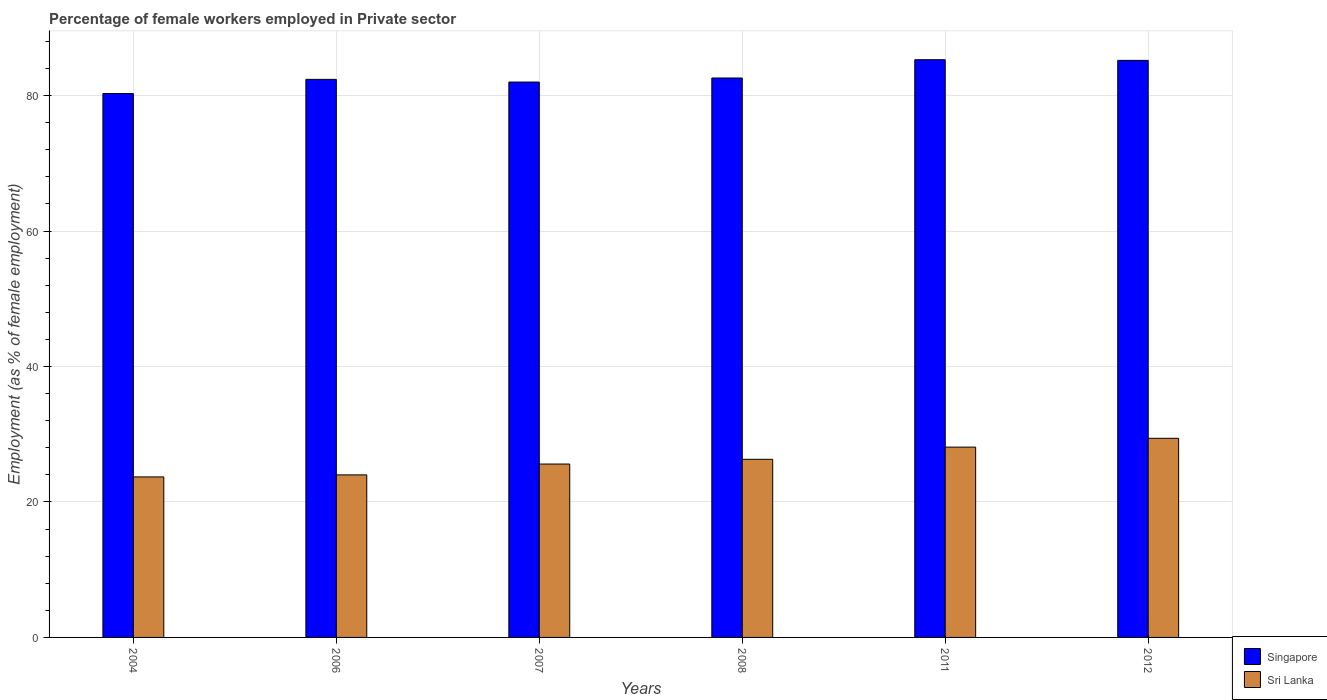How many different coloured bars are there?
Your response must be concise. 2. How many groups of bars are there?
Make the answer very short. 6. Are the number of bars per tick equal to the number of legend labels?
Offer a very short reply. Yes. Are the number of bars on each tick of the X-axis equal?
Your answer should be compact. Yes. In how many cases, is the number of bars for a given year not equal to the number of legend labels?
Provide a short and direct response. 0. What is the percentage of females employed in Private sector in Sri Lanka in 2007?
Offer a very short reply. 25.6. Across all years, what is the maximum percentage of females employed in Private sector in Singapore?
Provide a succinct answer. 85.3. Across all years, what is the minimum percentage of females employed in Private sector in Singapore?
Your answer should be compact. 80.3. What is the total percentage of females employed in Private sector in Singapore in the graph?
Provide a succinct answer. 497.8. What is the difference between the percentage of females employed in Private sector in Singapore in 2006 and that in 2012?
Your response must be concise. -2.8. What is the difference between the percentage of females employed in Private sector in Singapore in 2012 and the percentage of females employed in Private sector in Sri Lanka in 2004?
Ensure brevity in your answer.  61.5. What is the average percentage of females employed in Private sector in Singapore per year?
Your answer should be compact. 82.97. In the year 2011, what is the difference between the percentage of females employed in Private sector in Singapore and percentage of females employed in Private sector in Sri Lanka?
Provide a short and direct response. 57.2. What is the ratio of the percentage of females employed in Private sector in Singapore in 2006 to that in 2011?
Keep it short and to the point. 0.97. Is the percentage of females employed in Private sector in Sri Lanka in 2004 less than that in 2006?
Provide a succinct answer. Yes. What is the difference between the highest and the second highest percentage of females employed in Private sector in Singapore?
Your answer should be very brief. 0.1. What is the difference between the highest and the lowest percentage of females employed in Private sector in Sri Lanka?
Provide a short and direct response. 5.7. In how many years, is the percentage of females employed in Private sector in Sri Lanka greater than the average percentage of females employed in Private sector in Sri Lanka taken over all years?
Ensure brevity in your answer.  3. Is the sum of the percentage of females employed in Private sector in Singapore in 2007 and 2012 greater than the maximum percentage of females employed in Private sector in Sri Lanka across all years?
Offer a terse response. Yes. What does the 1st bar from the left in 2011 represents?
Offer a very short reply. Singapore. What does the 2nd bar from the right in 2006 represents?
Ensure brevity in your answer.  Singapore. Are all the bars in the graph horizontal?
Keep it short and to the point. No. How many years are there in the graph?
Provide a short and direct response. 6. What is the difference between two consecutive major ticks on the Y-axis?
Ensure brevity in your answer.  20. Are the values on the major ticks of Y-axis written in scientific E-notation?
Give a very brief answer. No. Does the graph contain any zero values?
Your answer should be compact. No. What is the title of the graph?
Ensure brevity in your answer.  Percentage of female workers employed in Private sector. What is the label or title of the X-axis?
Provide a succinct answer. Years. What is the label or title of the Y-axis?
Give a very brief answer. Employment (as % of female employment). What is the Employment (as % of female employment) in Singapore in 2004?
Give a very brief answer. 80.3. What is the Employment (as % of female employment) in Sri Lanka in 2004?
Provide a short and direct response. 23.7. What is the Employment (as % of female employment) of Singapore in 2006?
Keep it short and to the point. 82.4. What is the Employment (as % of female employment) in Sri Lanka in 2006?
Provide a short and direct response. 24. What is the Employment (as % of female employment) in Singapore in 2007?
Make the answer very short. 82. What is the Employment (as % of female employment) of Sri Lanka in 2007?
Give a very brief answer. 25.6. What is the Employment (as % of female employment) in Singapore in 2008?
Your answer should be compact. 82.6. What is the Employment (as % of female employment) in Sri Lanka in 2008?
Offer a very short reply. 26.3. What is the Employment (as % of female employment) in Singapore in 2011?
Keep it short and to the point. 85.3. What is the Employment (as % of female employment) of Sri Lanka in 2011?
Offer a very short reply. 28.1. What is the Employment (as % of female employment) in Singapore in 2012?
Give a very brief answer. 85.2. What is the Employment (as % of female employment) of Sri Lanka in 2012?
Give a very brief answer. 29.4. Across all years, what is the maximum Employment (as % of female employment) in Singapore?
Offer a very short reply. 85.3. Across all years, what is the maximum Employment (as % of female employment) in Sri Lanka?
Offer a very short reply. 29.4. Across all years, what is the minimum Employment (as % of female employment) of Singapore?
Ensure brevity in your answer.  80.3. Across all years, what is the minimum Employment (as % of female employment) in Sri Lanka?
Your answer should be very brief. 23.7. What is the total Employment (as % of female employment) in Singapore in the graph?
Provide a succinct answer. 497.8. What is the total Employment (as % of female employment) in Sri Lanka in the graph?
Offer a terse response. 157.1. What is the difference between the Employment (as % of female employment) of Sri Lanka in 2004 and that in 2006?
Your answer should be compact. -0.3. What is the difference between the Employment (as % of female employment) of Singapore in 2004 and that in 2007?
Ensure brevity in your answer.  -1.7. What is the difference between the Employment (as % of female employment) in Singapore in 2004 and that in 2008?
Your answer should be very brief. -2.3. What is the difference between the Employment (as % of female employment) of Sri Lanka in 2004 and that in 2008?
Make the answer very short. -2.6. What is the difference between the Employment (as % of female employment) of Sri Lanka in 2004 and that in 2011?
Provide a short and direct response. -4.4. What is the difference between the Employment (as % of female employment) in Singapore in 2006 and that in 2007?
Make the answer very short. 0.4. What is the difference between the Employment (as % of female employment) in Sri Lanka in 2006 and that in 2007?
Ensure brevity in your answer.  -1.6. What is the difference between the Employment (as % of female employment) in Singapore in 2006 and that in 2008?
Your response must be concise. -0.2. What is the difference between the Employment (as % of female employment) of Sri Lanka in 2006 and that in 2008?
Make the answer very short. -2.3. What is the difference between the Employment (as % of female employment) in Singapore in 2006 and that in 2012?
Your response must be concise. -2.8. What is the difference between the Employment (as % of female employment) in Sri Lanka in 2006 and that in 2012?
Your answer should be very brief. -5.4. What is the difference between the Employment (as % of female employment) of Singapore in 2007 and that in 2011?
Keep it short and to the point. -3.3. What is the difference between the Employment (as % of female employment) of Singapore in 2007 and that in 2012?
Keep it short and to the point. -3.2. What is the difference between the Employment (as % of female employment) in Sri Lanka in 2008 and that in 2011?
Offer a very short reply. -1.8. What is the difference between the Employment (as % of female employment) in Sri Lanka in 2008 and that in 2012?
Keep it short and to the point. -3.1. What is the difference between the Employment (as % of female employment) in Singapore in 2011 and that in 2012?
Give a very brief answer. 0.1. What is the difference between the Employment (as % of female employment) of Singapore in 2004 and the Employment (as % of female employment) of Sri Lanka in 2006?
Your answer should be compact. 56.3. What is the difference between the Employment (as % of female employment) in Singapore in 2004 and the Employment (as % of female employment) in Sri Lanka in 2007?
Offer a terse response. 54.7. What is the difference between the Employment (as % of female employment) in Singapore in 2004 and the Employment (as % of female employment) in Sri Lanka in 2008?
Offer a very short reply. 54. What is the difference between the Employment (as % of female employment) in Singapore in 2004 and the Employment (as % of female employment) in Sri Lanka in 2011?
Give a very brief answer. 52.2. What is the difference between the Employment (as % of female employment) of Singapore in 2004 and the Employment (as % of female employment) of Sri Lanka in 2012?
Give a very brief answer. 50.9. What is the difference between the Employment (as % of female employment) of Singapore in 2006 and the Employment (as % of female employment) of Sri Lanka in 2007?
Provide a succinct answer. 56.8. What is the difference between the Employment (as % of female employment) in Singapore in 2006 and the Employment (as % of female employment) in Sri Lanka in 2008?
Ensure brevity in your answer.  56.1. What is the difference between the Employment (as % of female employment) of Singapore in 2006 and the Employment (as % of female employment) of Sri Lanka in 2011?
Your answer should be very brief. 54.3. What is the difference between the Employment (as % of female employment) of Singapore in 2007 and the Employment (as % of female employment) of Sri Lanka in 2008?
Offer a very short reply. 55.7. What is the difference between the Employment (as % of female employment) in Singapore in 2007 and the Employment (as % of female employment) in Sri Lanka in 2011?
Ensure brevity in your answer.  53.9. What is the difference between the Employment (as % of female employment) in Singapore in 2007 and the Employment (as % of female employment) in Sri Lanka in 2012?
Make the answer very short. 52.6. What is the difference between the Employment (as % of female employment) of Singapore in 2008 and the Employment (as % of female employment) of Sri Lanka in 2011?
Ensure brevity in your answer.  54.5. What is the difference between the Employment (as % of female employment) in Singapore in 2008 and the Employment (as % of female employment) in Sri Lanka in 2012?
Offer a terse response. 53.2. What is the difference between the Employment (as % of female employment) of Singapore in 2011 and the Employment (as % of female employment) of Sri Lanka in 2012?
Your response must be concise. 55.9. What is the average Employment (as % of female employment) of Singapore per year?
Provide a short and direct response. 82.97. What is the average Employment (as % of female employment) of Sri Lanka per year?
Your answer should be very brief. 26.18. In the year 2004, what is the difference between the Employment (as % of female employment) in Singapore and Employment (as % of female employment) in Sri Lanka?
Ensure brevity in your answer.  56.6. In the year 2006, what is the difference between the Employment (as % of female employment) in Singapore and Employment (as % of female employment) in Sri Lanka?
Make the answer very short. 58.4. In the year 2007, what is the difference between the Employment (as % of female employment) in Singapore and Employment (as % of female employment) in Sri Lanka?
Provide a succinct answer. 56.4. In the year 2008, what is the difference between the Employment (as % of female employment) in Singapore and Employment (as % of female employment) in Sri Lanka?
Your answer should be very brief. 56.3. In the year 2011, what is the difference between the Employment (as % of female employment) of Singapore and Employment (as % of female employment) of Sri Lanka?
Offer a terse response. 57.2. In the year 2012, what is the difference between the Employment (as % of female employment) of Singapore and Employment (as % of female employment) of Sri Lanka?
Offer a terse response. 55.8. What is the ratio of the Employment (as % of female employment) in Singapore in 2004 to that in 2006?
Your answer should be very brief. 0.97. What is the ratio of the Employment (as % of female employment) in Sri Lanka in 2004 to that in 2006?
Offer a terse response. 0.99. What is the ratio of the Employment (as % of female employment) in Singapore in 2004 to that in 2007?
Keep it short and to the point. 0.98. What is the ratio of the Employment (as % of female employment) in Sri Lanka in 2004 to that in 2007?
Give a very brief answer. 0.93. What is the ratio of the Employment (as % of female employment) in Singapore in 2004 to that in 2008?
Your answer should be compact. 0.97. What is the ratio of the Employment (as % of female employment) of Sri Lanka in 2004 to that in 2008?
Give a very brief answer. 0.9. What is the ratio of the Employment (as % of female employment) of Singapore in 2004 to that in 2011?
Ensure brevity in your answer.  0.94. What is the ratio of the Employment (as % of female employment) in Sri Lanka in 2004 to that in 2011?
Make the answer very short. 0.84. What is the ratio of the Employment (as % of female employment) of Singapore in 2004 to that in 2012?
Offer a terse response. 0.94. What is the ratio of the Employment (as % of female employment) of Sri Lanka in 2004 to that in 2012?
Your answer should be compact. 0.81. What is the ratio of the Employment (as % of female employment) of Singapore in 2006 to that in 2007?
Provide a succinct answer. 1. What is the ratio of the Employment (as % of female employment) of Sri Lanka in 2006 to that in 2008?
Offer a terse response. 0.91. What is the ratio of the Employment (as % of female employment) of Sri Lanka in 2006 to that in 2011?
Your answer should be very brief. 0.85. What is the ratio of the Employment (as % of female employment) of Singapore in 2006 to that in 2012?
Provide a succinct answer. 0.97. What is the ratio of the Employment (as % of female employment) of Sri Lanka in 2006 to that in 2012?
Make the answer very short. 0.82. What is the ratio of the Employment (as % of female employment) of Singapore in 2007 to that in 2008?
Give a very brief answer. 0.99. What is the ratio of the Employment (as % of female employment) in Sri Lanka in 2007 to that in 2008?
Keep it short and to the point. 0.97. What is the ratio of the Employment (as % of female employment) in Singapore in 2007 to that in 2011?
Offer a very short reply. 0.96. What is the ratio of the Employment (as % of female employment) in Sri Lanka in 2007 to that in 2011?
Give a very brief answer. 0.91. What is the ratio of the Employment (as % of female employment) of Singapore in 2007 to that in 2012?
Your answer should be very brief. 0.96. What is the ratio of the Employment (as % of female employment) in Sri Lanka in 2007 to that in 2012?
Give a very brief answer. 0.87. What is the ratio of the Employment (as % of female employment) of Singapore in 2008 to that in 2011?
Your response must be concise. 0.97. What is the ratio of the Employment (as % of female employment) in Sri Lanka in 2008 to that in 2011?
Provide a succinct answer. 0.94. What is the ratio of the Employment (as % of female employment) of Singapore in 2008 to that in 2012?
Keep it short and to the point. 0.97. What is the ratio of the Employment (as % of female employment) in Sri Lanka in 2008 to that in 2012?
Offer a very short reply. 0.89. What is the ratio of the Employment (as % of female employment) in Sri Lanka in 2011 to that in 2012?
Offer a very short reply. 0.96. What is the difference between the highest and the second highest Employment (as % of female employment) in Sri Lanka?
Make the answer very short. 1.3. 